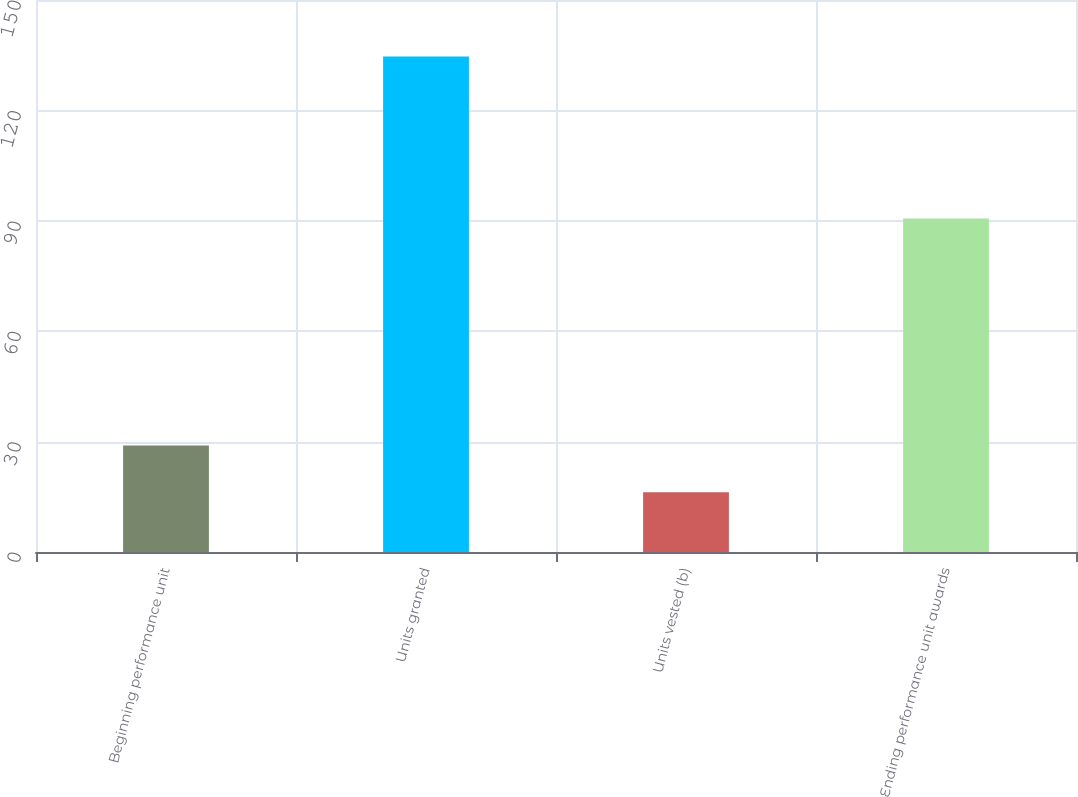<chart> <loc_0><loc_0><loc_500><loc_500><bar_chart><fcel>Beginning performance unit<fcel>Units granted<fcel>Units vested (b)<fcel>Ending performance unit awards<nl><fcel>28.91<fcel>134.68<fcel>16.25<fcel>90.64<nl></chart> 